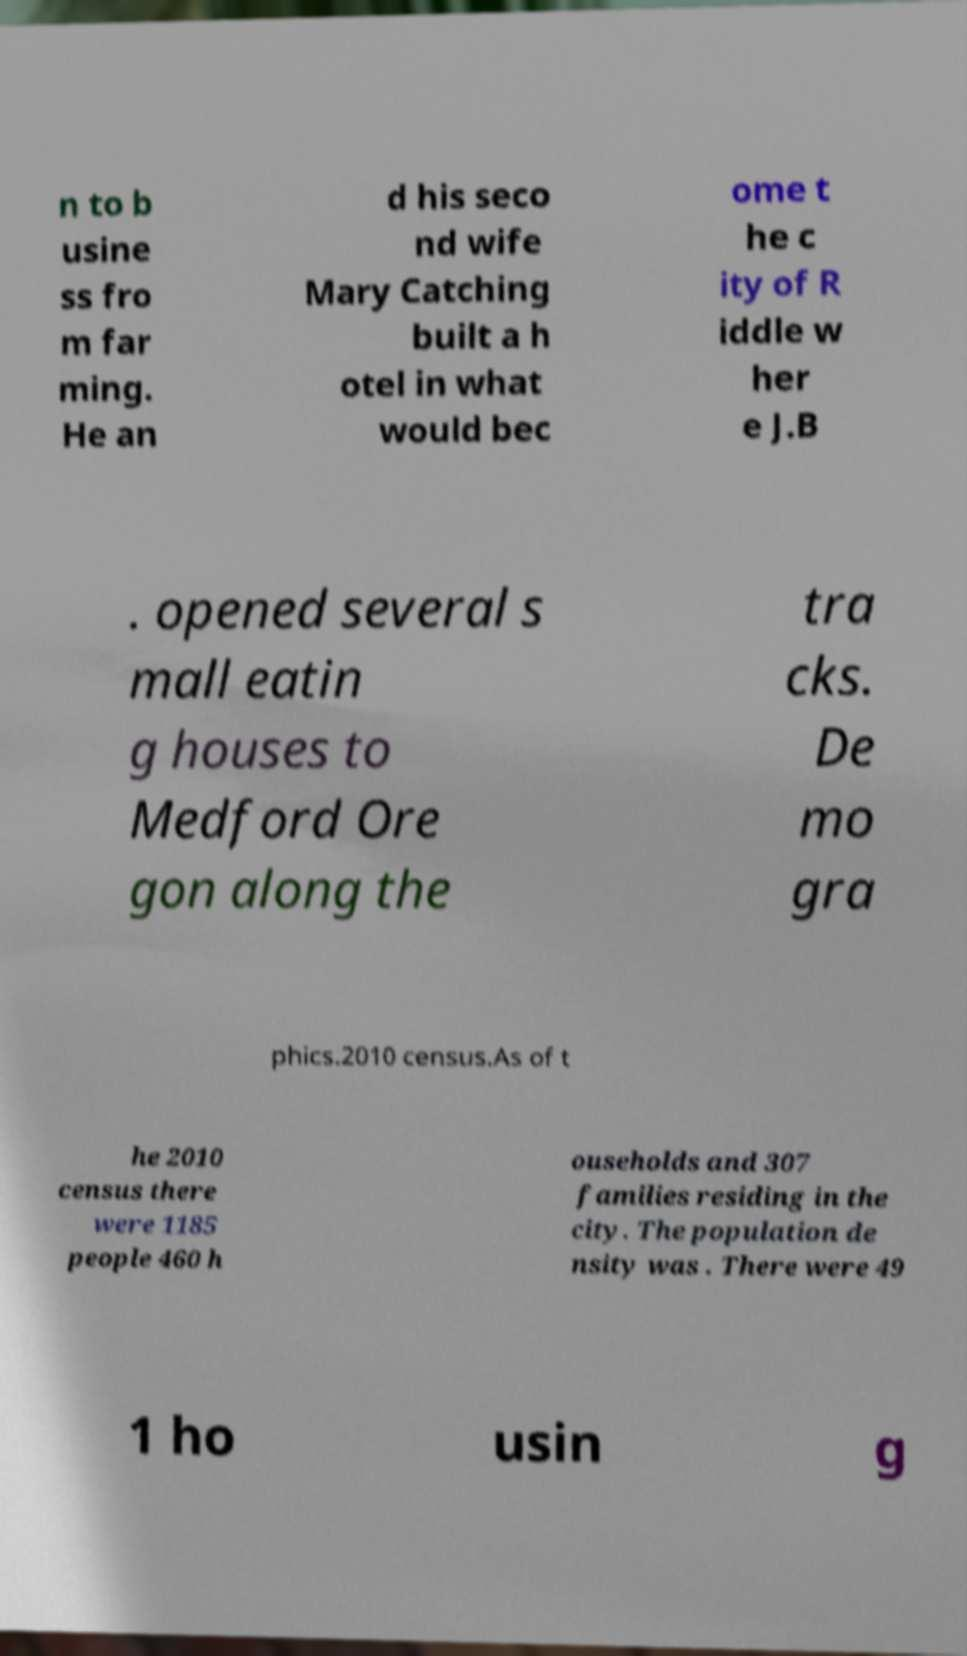There's text embedded in this image that I need extracted. Can you transcribe it verbatim? n to b usine ss fro m far ming. He an d his seco nd wife Mary Catching built a h otel in what would bec ome t he c ity of R iddle w her e J.B . opened several s mall eatin g houses to Medford Ore gon along the tra cks. De mo gra phics.2010 census.As of t he 2010 census there were 1185 people 460 h ouseholds and 307 families residing in the city. The population de nsity was . There were 49 1 ho usin g 